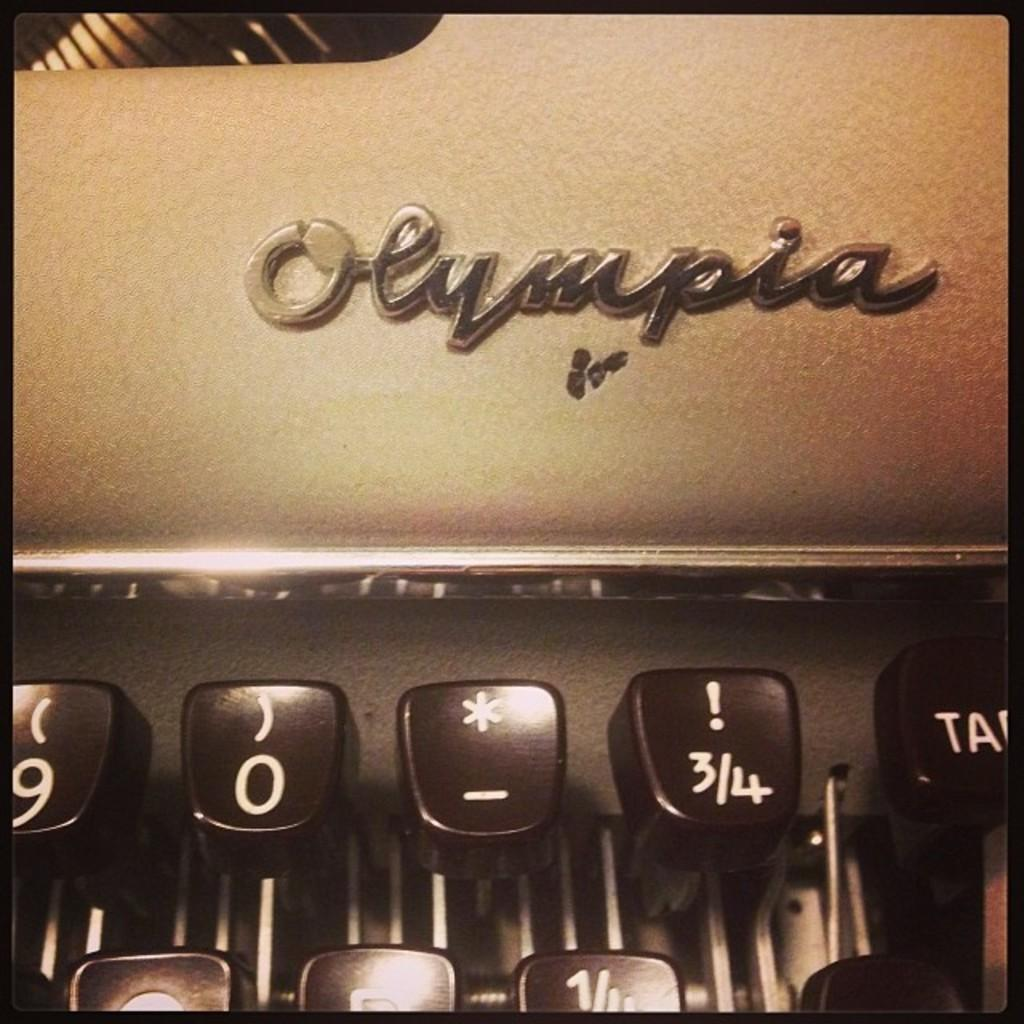Provide a one-sentence caption for the provided image. An old typewriter that shows upclose the brand Olympia logo. 